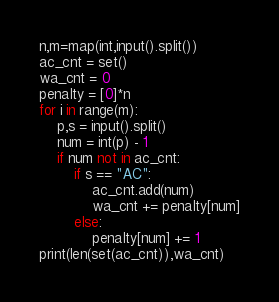<code> <loc_0><loc_0><loc_500><loc_500><_Python_>n,m=map(int,input().split())
ac_cnt = set()
wa_cnt = 0
penalty = [0]*n
for i in range(m):
    p,s = input().split()
    num = int(p) - 1
    if num not in ac_cnt:
        if s == "AC":
            ac_cnt.add(num)
            wa_cnt += penalty[num]
        else:
            penalty[num] += 1
print(len(set(ac_cnt)),wa_cnt)</code> 